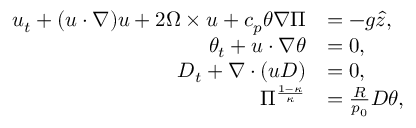<formula> <loc_0><loc_0><loc_500><loc_500>\begin{array} { r l } { u _ { t } + ( u \cdot \nabla ) u + 2 \Omega \times u + c _ { p } \theta \nabla \Pi } & { = - g \hat { z } , } \\ { \theta _ { t } + u \cdot \nabla \theta } & { = 0 , } \\ { D _ { t } + \nabla \cdot ( u D ) } & { = 0 , } \\ { \Pi ^ { \frac { 1 - \kappa } { \kappa } } } & { = \frac { R } { p _ { 0 } } D \theta , } \end{array}</formula> 